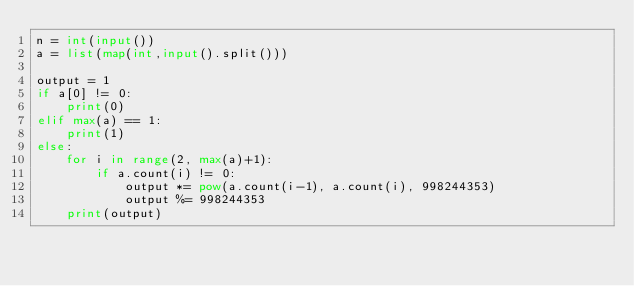<code> <loc_0><loc_0><loc_500><loc_500><_Python_>n = int(input())
a = list(map(int,input().split()))
 
output = 1
if a[0] != 0:
    print(0)
elif max(a) == 1:
    print(1)
else:
    for i in range(2, max(a)+1):
        if a.count(i) != 0:
            output *= pow(a.count(i-1), a.count(i), 998244353)
            output %= 998244353
    print(output)</code> 